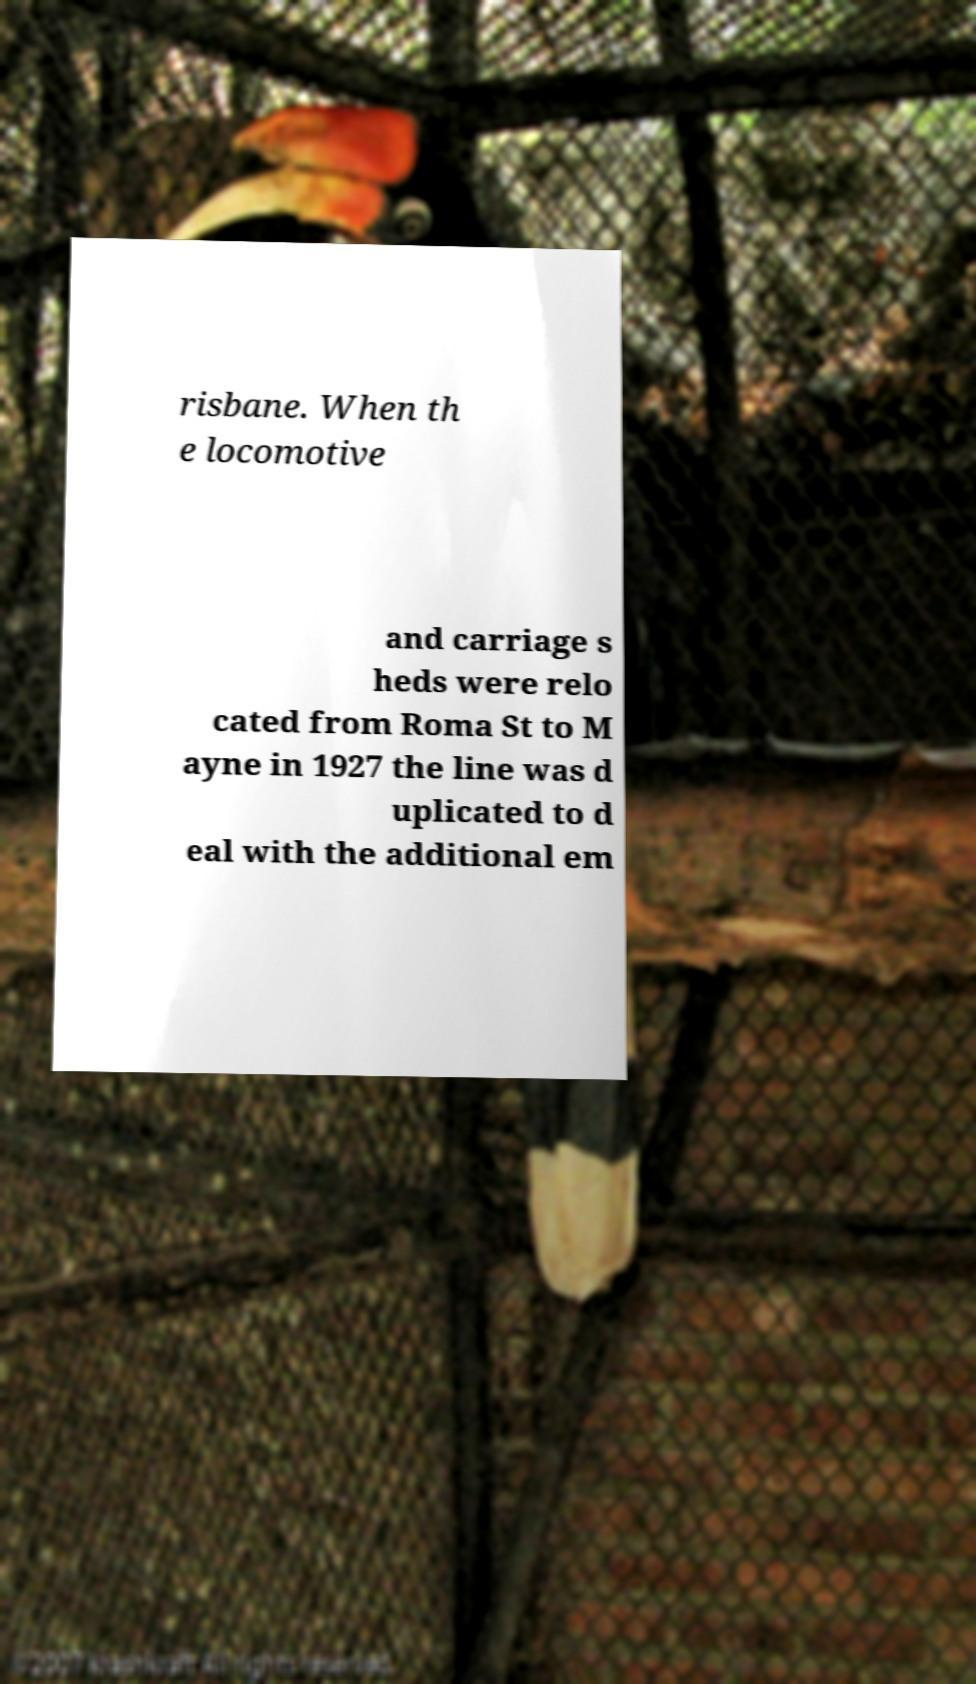Please identify and transcribe the text found in this image. risbane. When th e locomotive and carriage s heds were relo cated from Roma St to M ayne in 1927 the line was d uplicated to d eal with the additional em 